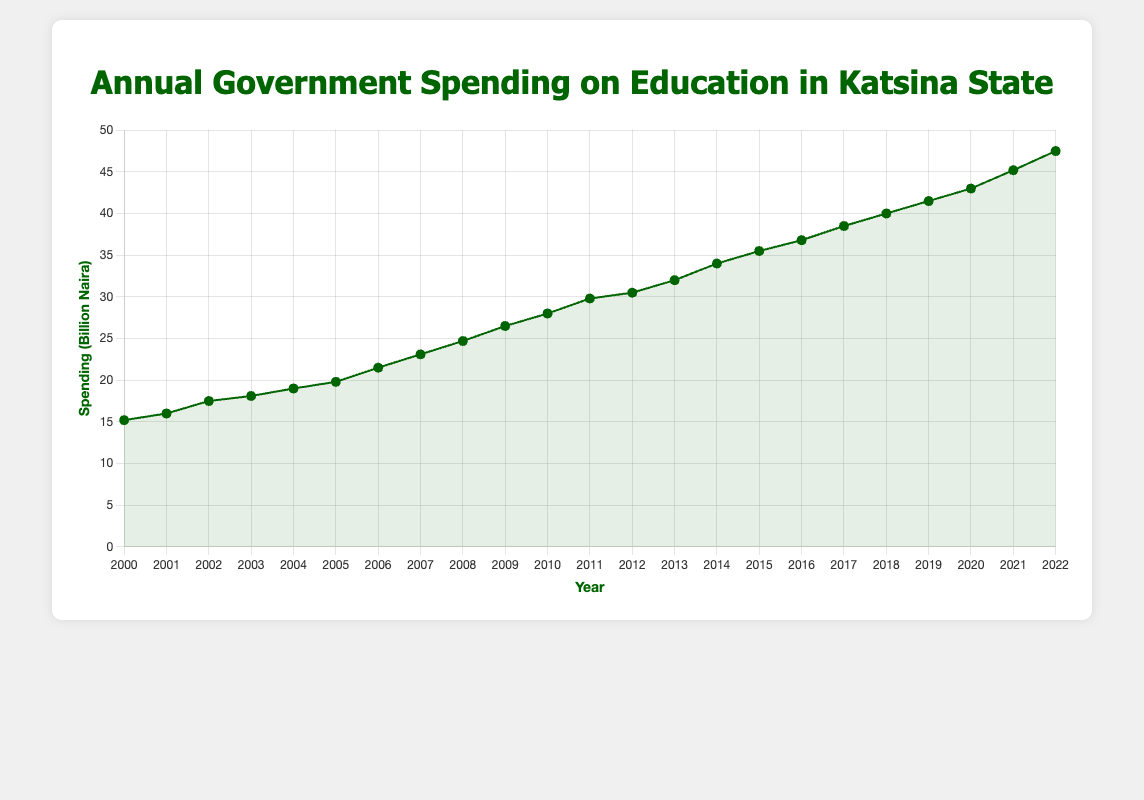What is the annual government spending on education in Katsina State in the year 2005? Refer to the data point corresponding to the year 2005 on the line chart.
Answer: 19.8 billion Naira How much did the education spending increase from 2000 to 2022? Subtract the spending in 2000 (15.2 billion Naira) from the spending in 2022 (47.5 billion Naira). 47.5 - 15.2 = 32.3 billion Naira
Answer: 32.3 billion Naira What is the average annual government spending on education from 2000 to 2010? Sum the education spending for the years 2000 to 2010 and divide by the number of years (11). (15.2 + 16.0 + 17.5 + 18.1 + 19.0 + 19.8 + 21.5 + 23.1 + 24.7 + 26.5 + 28.0) = 209.4, then 209.4 / 11 = 19.04 billion Naira
Answer: 19.04 billion Naira Which year saw the highest increase in government spending on education compared to the previous year? Calculate the yearly differences and identify the year with the highest increase. The largest increase is between 2008 (24.7) and 2009 (26.5), which is 1.8 billion Naira.
Answer: 2009 Compare the government spending on education in 2010 to that in 2006. Is it more or less? Compare the amounts for 2010 (28.0 billion Naira) and 2006 (21.5 billion Naira). 28.0 > 21.5.
Answer: More How does the height of the point for 2017 compare to the height of the point for 2015? Visually compare the vertical positions (heights) of the points for 2017 and 2015 on the line chart.
Answer: Higher Is there any year between 2000 and 2022 when the government spending on education decreased compared to the previous year? Scan the line chart to check for any downward trend periods. There is none; every year spending either increases or remains the same.
Answer: No How much was the increase in spending from 2018 to 2019? Subtract the spending amount for 2018 (40.0 billion Naira) from the amount for 2019 (41.5 billion Naira). 41.5 - 40.0 = 1.5 billion Naira
Answer: 1.5 billion Naira What is the median value of annual government spending on education from 2000 to 2022? Order the spending values and find the median (middle) value. Ordered values: [15.2, 16.0, 17.5, 18.1, 19.0, 19.8, 21.5, 23.1, 24.7, 26.5, 28.0, 29.8, 30.5, 32.0, 34.0, 35.5, 36.8, 38.5, 40.0, 41.5, 43.0, 45.2, 47.5]. The median is the 12th value: 29.8 billion Naira
Answer: 29.8 billion Naira Compare the visual representation of the point in 2020 to the point in 2021. Which one is higher? By looking at the line chart, compare the vertical position of the points for the years 2020 and 2021.
Answer: 2021 